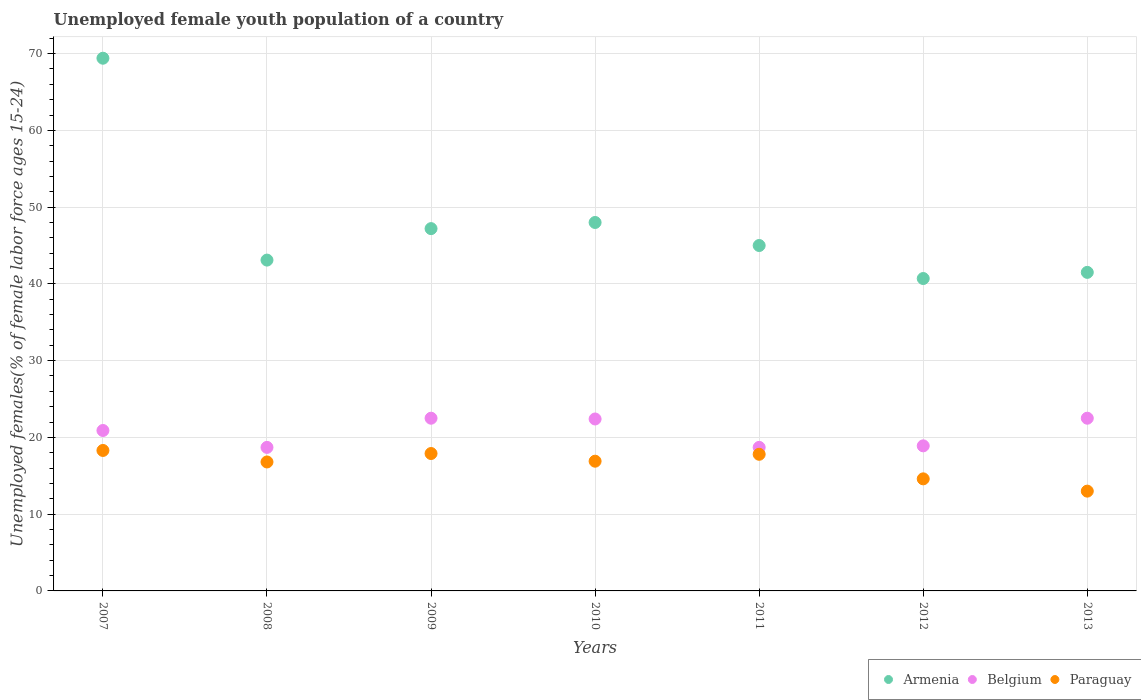Is the number of dotlines equal to the number of legend labels?
Provide a succinct answer. Yes. What is the percentage of unemployed female youth population in Armenia in 2009?
Give a very brief answer. 47.2. Across all years, what is the maximum percentage of unemployed female youth population in Paraguay?
Offer a terse response. 18.3. Across all years, what is the minimum percentage of unemployed female youth population in Belgium?
Provide a short and direct response. 18.7. In which year was the percentage of unemployed female youth population in Belgium minimum?
Give a very brief answer. 2008. What is the total percentage of unemployed female youth population in Armenia in the graph?
Your response must be concise. 334.9. What is the difference between the percentage of unemployed female youth population in Belgium in 2010 and that in 2012?
Provide a succinct answer. 3.5. What is the difference between the percentage of unemployed female youth population in Belgium in 2013 and the percentage of unemployed female youth population in Paraguay in 2009?
Give a very brief answer. 4.6. What is the average percentage of unemployed female youth population in Paraguay per year?
Your answer should be very brief. 16.47. In the year 2009, what is the difference between the percentage of unemployed female youth population in Armenia and percentage of unemployed female youth population in Belgium?
Your answer should be very brief. 24.7. In how many years, is the percentage of unemployed female youth population in Armenia greater than 24 %?
Offer a terse response. 7. What is the ratio of the percentage of unemployed female youth population in Belgium in 2007 to that in 2009?
Your response must be concise. 0.93. Is the percentage of unemployed female youth population in Armenia in 2009 less than that in 2010?
Your answer should be compact. Yes. What is the difference between the highest and the second highest percentage of unemployed female youth population in Armenia?
Your answer should be compact. 21.4. What is the difference between the highest and the lowest percentage of unemployed female youth population in Belgium?
Give a very brief answer. 3.8. Does the percentage of unemployed female youth population in Armenia monotonically increase over the years?
Provide a short and direct response. No. Is the percentage of unemployed female youth population in Armenia strictly greater than the percentage of unemployed female youth population in Belgium over the years?
Provide a succinct answer. Yes. Is the percentage of unemployed female youth population in Armenia strictly less than the percentage of unemployed female youth population in Belgium over the years?
Provide a short and direct response. No. How many years are there in the graph?
Provide a succinct answer. 7. Are the values on the major ticks of Y-axis written in scientific E-notation?
Your answer should be very brief. No. Does the graph contain any zero values?
Give a very brief answer. No. How many legend labels are there?
Give a very brief answer. 3. How are the legend labels stacked?
Make the answer very short. Horizontal. What is the title of the graph?
Make the answer very short. Unemployed female youth population of a country. What is the label or title of the X-axis?
Your response must be concise. Years. What is the label or title of the Y-axis?
Make the answer very short. Unemployed females(% of female labor force ages 15-24). What is the Unemployed females(% of female labor force ages 15-24) in Armenia in 2007?
Your answer should be very brief. 69.4. What is the Unemployed females(% of female labor force ages 15-24) of Belgium in 2007?
Offer a terse response. 20.9. What is the Unemployed females(% of female labor force ages 15-24) in Paraguay in 2007?
Offer a very short reply. 18.3. What is the Unemployed females(% of female labor force ages 15-24) of Armenia in 2008?
Keep it short and to the point. 43.1. What is the Unemployed females(% of female labor force ages 15-24) of Belgium in 2008?
Provide a short and direct response. 18.7. What is the Unemployed females(% of female labor force ages 15-24) in Paraguay in 2008?
Your answer should be very brief. 16.8. What is the Unemployed females(% of female labor force ages 15-24) in Armenia in 2009?
Ensure brevity in your answer.  47.2. What is the Unemployed females(% of female labor force ages 15-24) of Paraguay in 2009?
Offer a very short reply. 17.9. What is the Unemployed females(% of female labor force ages 15-24) of Armenia in 2010?
Your answer should be very brief. 48. What is the Unemployed females(% of female labor force ages 15-24) in Belgium in 2010?
Your answer should be compact. 22.4. What is the Unemployed females(% of female labor force ages 15-24) in Paraguay in 2010?
Make the answer very short. 16.9. What is the Unemployed females(% of female labor force ages 15-24) in Armenia in 2011?
Make the answer very short. 45. What is the Unemployed females(% of female labor force ages 15-24) in Belgium in 2011?
Make the answer very short. 18.7. What is the Unemployed females(% of female labor force ages 15-24) of Paraguay in 2011?
Provide a succinct answer. 17.8. What is the Unemployed females(% of female labor force ages 15-24) in Armenia in 2012?
Offer a terse response. 40.7. What is the Unemployed females(% of female labor force ages 15-24) of Belgium in 2012?
Give a very brief answer. 18.9. What is the Unemployed females(% of female labor force ages 15-24) in Paraguay in 2012?
Your answer should be very brief. 14.6. What is the Unemployed females(% of female labor force ages 15-24) in Armenia in 2013?
Your response must be concise. 41.5. Across all years, what is the maximum Unemployed females(% of female labor force ages 15-24) in Armenia?
Provide a succinct answer. 69.4. Across all years, what is the maximum Unemployed females(% of female labor force ages 15-24) in Belgium?
Ensure brevity in your answer.  22.5. Across all years, what is the maximum Unemployed females(% of female labor force ages 15-24) of Paraguay?
Ensure brevity in your answer.  18.3. Across all years, what is the minimum Unemployed females(% of female labor force ages 15-24) of Armenia?
Provide a short and direct response. 40.7. Across all years, what is the minimum Unemployed females(% of female labor force ages 15-24) in Belgium?
Your answer should be compact. 18.7. What is the total Unemployed females(% of female labor force ages 15-24) in Armenia in the graph?
Your answer should be very brief. 334.9. What is the total Unemployed females(% of female labor force ages 15-24) in Belgium in the graph?
Your answer should be very brief. 144.6. What is the total Unemployed females(% of female labor force ages 15-24) of Paraguay in the graph?
Your response must be concise. 115.3. What is the difference between the Unemployed females(% of female labor force ages 15-24) in Armenia in 2007 and that in 2008?
Provide a succinct answer. 26.3. What is the difference between the Unemployed females(% of female labor force ages 15-24) of Paraguay in 2007 and that in 2009?
Your answer should be compact. 0.4. What is the difference between the Unemployed females(% of female labor force ages 15-24) in Armenia in 2007 and that in 2010?
Give a very brief answer. 21.4. What is the difference between the Unemployed females(% of female labor force ages 15-24) of Paraguay in 2007 and that in 2010?
Make the answer very short. 1.4. What is the difference between the Unemployed females(% of female labor force ages 15-24) of Armenia in 2007 and that in 2011?
Make the answer very short. 24.4. What is the difference between the Unemployed females(% of female labor force ages 15-24) in Paraguay in 2007 and that in 2011?
Ensure brevity in your answer.  0.5. What is the difference between the Unemployed females(% of female labor force ages 15-24) in Armenia in 2007 and that in 2012?
Your answer should be compact. 28.7. What is the difference between the Unemployed females(% of female labor force ages 15-24) in Belgium in 2007 and that in 2012?
Your response must be concise. 2. What is the difference between the Unemployed females(% of female labor force ages 15-24) in Paraguay in 2007 and that in 2012?
Give a very brief answer. 3.7. What is the difference between the Unemployed females(% of female labor force ages 15-24) of Armenia in 2007 and that in 2013?
Provide a short and direct response. 27.9. What is the difference between the Unemployed females(% of female labor force ages 15-24) of Belgium in 2007 and that in 2013?
Provide a short and direct response. -1.6. What is the difference between the Unemployed females(% of female labor force ages 15-24) of Paraguay in 2007 and that in 2013?
Offer a terse response. 5.3. What is the difference between the Unemployed females(% of female labor force ages 15-24) of Armenia in 2008 and that in 2009?
Offer a very short reply. -4.1. What is the difference between the Unemployed females(% of female labor force ages 15-24) of Belgium in 2008 and that in 2009?
Offer a terse response. -3.8. What is the difference between the Unemployed females(% of female labor force ages 15-24) in Armenia in 2008 and that in 2011?
Your answer should be very brief. -1.9. What is the difference between the Unemployed females(% of female labor force ages 15-24) in Belgium in 2008 and that in 2011?
Ensure brevity in your answer.  0. What is the difference between the Unemployed females(% of female labor force ages 15-24) in Belgium in 2008 and that in 2012?
Keep it short and to the point. -0.2. What is the difference between the Unemployed females(% of female labor force ages 15-24) of Paraguay in 2008 and that in 2012?
Give a very brief answer. 2.2. What is the difference between the Unemployed females(% of female labor force ages 15-24) of Belgium in 2008 and that in 2013?
Keep it short and to the point. -3.8. What is the difference between the Unemployed females(% of female labor force ages 15-24) in Paraguay in 2008 and that in 2013?
Give a very brief answer. 3.8. What is the difference between the Unemployed females(% of female labor force ages 15-24) of Belgium in 2009 and that in 2010?
Ensure brevity in your answer.  0.1. What is the difference between the Unemployed females(% of female labor force ages 15-24) in Armenia in 2009 and that in 2011?
Make the answer very short. 2.2. What is the difference between the Unemployed females(% of female labor force ages 15-24) of Paraguay in 2009 and that in 2011?
Ensure brevity in your answer.  0.1. What is the difference between the Unemployed females(% of female labor force ages 15-24) of Belgium in 2009 and that in 2012?
Give a very brief answer. 3.6. What is the difference between the Unemployed females(% of female labor force ages 15-24) of Armenia in 2009 and that in 2013?
Ensure brevity in your answer.  5.7. What is the difference between the Unemployed females(% of female labor force ages 15-24) in Belgium in 2009 and that in 2013?
Your answer should be very brief. 0. What is the difference between the Unemployed females(% of female labor force ages 15-24) in Paraguay in 2009 and that in 2013?
Your answer should be very brief. 4.9. What is the difference between the Unemployed females(% of female labor force ages 15-24) in Armenia in 2010 and that in 2011?
Ensure brevity in your answer.  3. What is the difference between the Unemployed females(% of female labor force ages 15-24) in Paraguay in 2010 and that in 2011?
Make the answer very short. -0.9. What is the difference between the Unemployed females(% of female labor force ages 15-24) of Belgium in 2010 and that in 2012?
Your response must be concise. 3.5. What is the difference between the Unemployed females(% of female labor force ages 15-24) in Paraguay in 2010 and that in 2012?
Offer a terse response. 2.3. What is the difference between the Unemployed females(% of female labor force ages 15-24) in Armenia in 2010 and that in 2013?
Your response must be concise. 6.5. What is the difference between the Unemployed females(% of female labor force ages 15-24) of Belgium in 2011 and that in 2012?
Give a very brief answer. -0.2. What is the difference between the Unemployed females(% of female labor force ages 15-24) of Paraguay in 2011 and that in 2012?
Your answer should be very brief. 3.2. What is the difference between the Unemployed females(% of female labor force ages 15-24) in Armenia in 2011 and that in 2013?
Offer a terse response. 3.5. What is the difference between the Unemployed females(% of female labor force ages 15-24) of Belgium in 2011 and that in 2013?
Keep it short and to the point. -3.8. What is the difference between the Unemployed females(% of female labor force ages 15-24) of Belgium in 2012 and that in 2013?
Keep it short and to the point. -3.6. What is the difference between the Unemployed females(% of female labor force ages 15-24) in Armenia in 2007 and the Unemployed females(% of female labor force ages 15-24) in Belgium in 2008?
Make the answer very short. 50.7. What is the difference between the Unemployed females(% of female labor force ages 15-24) in Armenia in 2007 and the Unemployed females(% of female labor force ages 15-24) in Paraguay in 2008?
Provide a short and direct response. 52.6. What is the difference between the Unemployed females(% of female labor force ages 15-24) in Armenia in 2007 and the Unemployed females(% of female labor force ages 15-24) in Belgium in 2009?
Your response must be concise. 46.9. What is the difference between the Unemployed females(% of female labor force ages 15-24) in Armenia in 2007 and the Unemployed females(% of female labor force ages 15-24) in Paraguay in 2009?
Your response must be concise. 51.5. What is the difference between the Unemployed females(% of female labor force ages 15-24) in Belgium in 2007 and the Unemployed females(% of female labor force ages 15-24) in Paraguay in 2009?
Keep it short and to the point. 3. What is the difference between the Unemployed females(% of female labor force ages 15-24) of Armenia in 2007 and the Unemployed females(% of female labor force ages 15-24) of Belgium in 2010?
Your answer should be very brief. 47. What is the difference between the Unemployed females(% of female labor force ages 15-24) in Armenia in 2007 and the Unemployed females(% of female labor force ages 15-24) in Paraguay in 2010?
Your answer should be very brief. 52.5. What is the difference between the Unemployed females(% of female labor force ages 15-24) of Armenia in 2007 and the Unemployed females(% of female labor force ages 15-24) of Belgium in 2011?
Make the answer very short. 50.7. What is the difference between the Unemployed females(% of female labor force ages 15-24) of Armenia in 2007 and the Unemployed females(% of female labor force ages 15-24) of Paraguay in 2011?
Keep it short and to the point. 51.6. What is the difference between the Unemployed females(% of female labor force ages 15-24) in Armenia in 2007 and the Unemployed females(% of female labor force ages 15-24) in Belgium in 2012?
Your response must be concise. 50.5. What is the difference between the Unemployed females(% of female labor force ages 15-24) of Armenia in 2007 and the Unemployed females(% of female labor force ages 15-24) of Paraguay in 2012?
Keep it short and to the point. 54.8. What is the difference between the Unemployed females(% of female labor force ages 15-24) of Belgium in 2007 and the Unemployed females(% of female labor force ages 15-24) of Paraguay in 2012?
Offer a terse response. 6.3. What is the difference between the Unemployed females(% of female labor force ages 15-24) of Armenia in 2007 and the Unemployed females(% of female labor force ages 15-24) of Belgium in 2013?
Your answer should be compact. 46.9. What is the difference between the Unemployed females(% of female labor force ages 15-24) in Armenia in 2007 and the Unemployed females(% of female labor force ages 15-24) in Paraguay in 2013?
Offer a terse response. 56.4. What is the difference between the Unemployed females(% of female labor force ages 15-24) in Armenia in 2008 and the Unemployed females(% of female labor force ages 15-24) in Belgium in 2009?
Your response must be concise. 20.6. What is the difference between the Unemployed females(% of female labor force ages 15-24) in Armenia in 2008 and the Unemployed females(% of female labor force ages 15-24) in Paraguay in 2009?
Ensure brevity in your answer.  25.2. What is the difference between the Unemployed females(% of female labor force ages 15-24) in Armenia in 2008 and the Unemployed females(% of female labor force ages 15-24) in Belgium in 2010?
Ensure brevity in your answer.  20.7. What is the difference between the Unemployed females(% of female labor force ages 15-24) of Armenia in 2008 and the Unemployed females(% of female labor force ages 15-24) of Paraguay in 2010?
Offer a very short reply. 26.2. What is the difference between the Unemployed females(% of female labor force ages 15-24) in Armenia in 2008 and the Unemployed females(% of female labor force ages 15-24) in Belgium in 2011?
Keep it short and to the point. 24.4. What is the difference between the Unemployed females(% of female labor force ages 15-24) of Armenia in 2008 and the Unemployed females(% of female labor force ages 15-24) of Paraguay in 2011?
Provide a short and direct response. 25.3. What is the difference between the Unemployed females(% of female labor force ages 15-24) of Belgium in 2008 and the Unemployed females(% of female labor force ages 15-24) of Paraguay in 2011?
Keep it short and to the point. 0.9. What is the difference between the Unemployed females(% of female labor force ages 15-24) in Armenia in 2008 and the Unemployed females(% of female labor force ages 15-24) in Belgium in 2012?
Provide a short and direct response. 24.2. What is the difference between the Unemployed females(% of female labor force ages 15-24) of Armenia in 2008 and the Unemployed females(% of female labor force ages 15-24) of Belgium in 2013?
Offer a terse response. 20.6. What is the difference between the Unemployed females(% of female labor force ages 15-24) in Armenia in 2008 and the Unemployed females(% of female labor force ages 15-24) in Paraguay in 2013?
Offer a very short reply. 30.1. What is the difference between the Unemployed females(% of female labor force ages 15-24) in Belgium in 2008 and the Unemployed females(% of female labor force ages 15-24) in Paraguay in 2013?
Give a very brief answer. 5.7. What is the difference between the Unemployed females(% of female labor force ages 15-24) of Armenia in 2009 and the Unemployed females(% of female labor force ages 15-24) of Belgium in 2010?
Offer a terse response. 24.8. What is the difference between the Unemployed females(% of female labor force ages 15-24) of Armenia in 2009 and the Unemployed females(% of female labor force ages 15-24) of Paraguay in 2010?
Offer a terse response. 30.3. What is the difference between the Unemployed females(% of female labor force ages 15-24) in Belgium in 2009 and the Unemployed females(% of female labor force ages 15-24) in Paraguay in 2010?
Ensure brevity in your answer.  5.6. What is the difference between the Unemployed females(% of female labor force ages 15-24) in Armenia in 2009 and the Unemployed females(% of female labor force ages 15-24) in Paraguay in 2011?
Your answer should be compact. 29.4. What is the difference between the Unemployed females(% of female labor force ages 15-24) in Belgium in 2009 and the Unemployed females(% of female labor force ages 15-24) in Paraguay in 2011?
Keep it short and to the point. 4.7. What is the difference between the Unemployed females(% of female labor force ages 15-24) of Armenia in 2009 and the Unemployed females(% of female labor force ages 15-24) of Belgium in 2012?
Your response must be concise. 28.3. What is the difference between the Unemployed females(% of female labor force ages 15-24) of Armenia in 2009 and the Unemployed females(% of female labor force ages 15-24) of Paraguay in 2012?
Offer a terse response. 32.6. What is the difference between the Unemployed females(% of female labor force ages 15-24) in Armenia in 2009 and the Unemployed females(% of female labor force ages 15-24) in Belgium in 2013?
Keep it short and to the point. 24.7. What is the difference between the Unemployed females(% of female labor force ages 15-24) of Armenia in 2009 and the Unemployed females(% of female labor force ages 15-24) of Paraguay in 2013?
Offer a terse response. 34.2. What is the difference between the Unemployed females(% of female labor force ages 15-24) of Belgium in 2009 and the Unemployed females(% of female labor force ages 15-24) of Paraguay in 2013?
Offer a very short reply. 9.5. What is the difference between the Unemployed females(% of female labor force ages 15-24) in Armenia in 2010 and the Unemployed females(% of female labor force ages 15-24) in Belgium in 2011?
Provide a succinct answer. 29.3. What is the difference between the Unemployed females(% of female labor force ages 15-24) in Armenia in 2010 and the Unemployed females(% of female labor force ages 15-24) in Paraguay in 2011?
Give a very brief answer. 30.2. What is the difference between the Unemployed females(% of female labor force ages 15-24) in Armenia in 2010 and the Unemployed females(% of female labor force ages 15-24) in Belgium in 2012?
Your response must be concise. 29.1. What is the difference between the Unemployed females(% of female labor force ages 15-24) of Armenia in 2010 and the Unemployed females(% of female labor force ages 15-24) of Paraguay in 2012?
Offer a very short reply. 33.4. What is the difference between the Unemployed females(% of female labor force ages 15-24) of Belgium in 2010 and the Unemployed females(% of female labor force ages 15-24) of Paraguay in 2012?
Provide a short and direct response. 7.8. What is the difference between the Unemployed females(% of female labor force ages 15-24) in Armenia in 2010 and the Unemployed females(% of female labor force ages 15-24) in Paraguay in 2013?
Your answer should be very brief. 35. What is the difference between the Unemployed females(% of female labor force ages 15-24) in Armenia in 2011 and the Unemployed females(% of female labor force ages 15-24) in Belgium in 2012?
Provide a succinct answer. 26.1. What is the difference between the Unemployed females(% of female labor force ages 15-24) of Armenia in 2011 and the Unemployed females(% of female labor force ages 15-24) of Paraguay in 2012?
Keep it short and to the point. 30.4. What is the difference between the Unemployed females(% of female labor force ages 15-24) in Armenia in 2011 and the Unemployed females(% of female labor force ages 15-24) in Belgium in 2013?
Provide a short and direct response. 22.5. What is the difference between the Unemployed females(% of female labor force ages 15-24) of Belgium in 2011 and the Unemployed females(% of female labor force ages 15-24) of Paraguay in 2013?
Provide a succinct answer. 5.7. What is the difference between the Unemployed females(% of female labor force ages 15-24) in Armenia in 2012 and the Unemployed females(% of female labor force ages 15-24) in Paraguay in 2013?
Your answer should be very brief. 27.7. What is the difference between the Unemployed females(% of female labor force ages 15-24) of Belgium in 2012 and the Unemployed females(% of female labor force ages 15-24) of Paraguay in 2013?
Give a very brief answer. 5.9. What is the average Unemployed females(% of female labor force ages 15-24) of Armenia per year?
Make the answer very short. 47.84. What is the average Unemployed females(% of female labor force ages 15-24) of Belgium per year?
Give a very brief answer. 20.66. What is the average Unemployed females(% of female labor force ages 15-24) in Paraguay per year?
Your response must be concise. 16.47. In the year 2007, what is the difference between the Unemployed females(% of female labor force ages 15-24) of Armenia and Unemployed females(% of female labor force ages 15-24) of Belgium?
Provide a succinct answer. 48.5. In the year 2007, what is the difference between the Unemployed females(% of female labor force ages 15-24) of Armenia and Unemployed females(% of female labor force ages 15-24) of Paraguay?
Your answer should be very brief. 51.1. In the year 2007, what is the difference between the Unemployed females(% of female labor force ages 15-24) of Belgium and Unemployed females(% of female labor force ages 15-24) of Paraguay?
Make the answer very short. 2.6. In the year 2008, what is the difference between the Unemployed females(% of female labor force ages 15-24) of Armenia and Unemployed females(% of female labor force ages 15-24) of Belgium?
Offer a terse response. 24.4. In the year 2008, what is the difference between the Unemployed females(% of female labor force ages 15-24) of Armenia and Unemployed females(% of female labor force ages 15-24) of Paraguay?
Offer a very short reply. 26.3. In the year 2009, what is the difference between the Unemployed females(% of female labor force ages 15-24) in Armenia and Unemployed females(% of female labor force ages 15-24) in Belgium?
Offer a very short reply. 24.7. In the year 2009, what is the difference between the Unemployed females(% of female labor force ages 15-24) of Armenia and Unemployed females(% of female labor force ages 15-24) of Paraguay?
Make the answer very short. 29.3. In the year 2009, what is the difference between the Unemployed females(% of female labor force ages 15-24) of Belgium and Unemployed females(% of female labor force ages 15-24) of Paraguay?
Offer a very short reply. 4.6. In the year 2010, what is the difference between the Unemployed females(% of female labor force ages 15-24) in Armenia and Unemployed females(% of female labor force ages 15-24) in Belgium?
Give a very brief answer. 25.6. In the year 2010, what is the difference between the Unemployed females(% of female labor force ages 15-24) in Armenia and Unemployed females(% of female labor force ages 15-24) in Paraguay?
Offer a terse response. 31.1. In the year 2011, what is the difference between the Unemployed females(% of female labor force ages 15-24) of Armenia and Unemployed females(% of female labor force ages 15-24) of Belgium?
Your answer should be very brief. 26.3. In the year 2011, what is the difference between the Unemployed females(% of female labor force ages 15-24) in Armenia and Unemployed females(% of female labor force ages 15-24) in Paraguay?
Provide a succinct answer. 27.2. In the year 2011, what is the difference between the Unemployed females(% of female labor force ages 15-24) in Belgium and Unemployed females(% of female labor force ages 15-24) in Paraguay?
Your response must be concise. 0.9. In the year 2012, what is the difference between the Unemployed females(% of female labor force ages 15-24) of Armenia and Unemployed females(% of female labor force ages 15-24) of Belgium?
Keep it short and to the point. 21.8. In the year 2012, what is the difference between the Unemployed females(% of female labor force ages 15-24) of Armenia and Unemployed females(% of female labor force ages 15-24) of Paraguay?
Ensure brevity in your answer.  26.1. In the year 2013, what is the difference between the Unemployed females(% of female labor force ages 15-24) of Armenia and Unemployed females(% of female labor force ages 15-24) of Belgium?
Provide a succinct answer. 19. In the year 2013, what is the difference between the Unemployed females(% of female labor force ages 15-24) of Armenia and Unemployed females(% of female labor force ages 15-24) of Paraguay?
Ensure brevity in your answer.  28.5. In the year 2013, what is the difference between the Unemployed females(% of female labor force ages 15-24) of Belgium and Unemployed females(% of female labor force ages 15-24) of Paraguay?
Your answer should be very brief. 9.5. What is the ratio of the Unemployed females(% of female labor force ages 15-24) in Armenia in 2007 to that in 2008?
Provide a succinct answer. 1.61. What is the ratio of the Unemployed females(% of female labor force ages 15-24) in Belgium in 2007 to that in 2008?
Your answer should be compact. 1.12. What is the ratio of the Unemployed females(% of female labor force ages 15-24) in Paraguay in 2007 to that in 2008?
Keep it short and to the point. 1.09. What is the ratio of the Unemployed females(% of female labor force ages 15-24) in Armenia in 2007 to that in 2009?
Offer a terse response. 1.47. What is the ratio of the Unemployed females(% of female labor force ages 15-24) of Belgium in 2007 to that in 2009?
Keep it short and to the point. 0.93. What is the ratio of the Unemployed females(% of female labor force ages 15-24) in Paraguay in 2007 to that in 2009?
Your response must be concise. 1.02. What is the ratio of the Unemployed females(% of female labor force ages 15-24) of Armenia in 2007 to that in 2010?
Your response must be concise. 1.45. What is the ratio of the Unemployed females(% of female labor force ages 15-24) of Belgium in 2007 to that in 2010?
Give a very brief answer. 0.93. What is the ratio of the Unemployed females(% of female labor force ages 15-24) of Paraguay in 2007 to that in 2010?
Keep it short and to the point. 1.08. What is the ratio of the Unemployed females(% of female labor force ages 15-24) of Armenia in 2007 to that in 2011?
Ensure brevity in your answer.  1.54. What is the ratio of the Unemployed females(% of female labor force ages 15-24) in Belgium in 2007 to that in 2011?
Keep it short and to the point. 1.12. What is the ratio of the Unemployed females(% of female labor force ages 15-24) in Paraguay in 2007 to that in 2011?
Your answer should be very brief. 1.03. What is the ratio of the Unemployed females(% of female labor force ages 15-24) of Armenia in 2007 to that in 2012?
Your answer should be compact. 1.71. What is the ratio of the Unemployed females(% of female labor force ages 15-24) in Belgium in 2007 to that in 2012?
Offer a very short reply. 1.11. What is the ratio of the Unemployed females(% of female labor force ages 15-24) of Paraguay in 2007 to that in 2012?
Make the answer very short. 1.25. What is the ratio of the Unemployed females(% of female labor force ages 15-24) in Armenia in 2007 to that in 2013?
Offer a very short reply. 1.67. What is the ratio of the Unemployed females(% of female labor force ages 15-24) in Belgium in 2007 to that in 2013?
Offer a terse response. 0.93. What is the ratio of the Unemployed females(% of female labor force ages 15-24) in Paraguay in 2007 to that in 2013?
Offer a terse response. 1.41. What is the ratio of the Unemployed females(% of female labor force ages 15-24) in Armenia in 2008 to that in 2009?
Provide a succinct answer. 0.91. What is the ratio of the Unemployed females(% of female labor force ages 15-24) of Belgium in 2008 to that in 2009?
Your answer should be compact. 0.83. What is the ratio of the Unemployed females(% of female labor force ages 15-24) in Paraguay in 2008 to that in 2009?
Offer a terse response. 0.94. What is the ratio of the Unemployed females(% of female labor force ages 15-24) of Armenia in 2008 to that in 2010?
Ensure brevity in your answer.  0.9. What is the ratio of the Unemployed females(% of female labor force ages 15-24) of Belgium in 2008 to that in 2010?
Offer a very short reply. 0.83. What is the ratio of the Unemployed females(% of female labor force ages 15-24) in Armenia in 2008 to that in 2011?
Offer a terse response. 0.96. What is the ratio of the Unemployed females(% of female labor force ages 15-24) of Paraguay in 2008 to that in 2011?
Make the answer very short. 0.94. What is the ratio of the Unemployed females(% of female labor force ages 15-24) in Armenia in 2008 to that in 2012?
Your answer should be compact. 1.06. What is the ratio of the Unemployed females(% of female labor force ages 15-24) in Belgium in 2008 to that in 2012?
Make the answer very short. 0.99. What is the ratio of the Unemployed females(% of female labor force ages 15-24) of Paraguay in 2008 to that in 2012?
Offer a very short reply. 1.15. What is the ratio of the Unemployed females(% of female labor force ages 15-24) in Armenia in 2008 to that in 2013?
Ensure brevity in your answer.  1.04. What is the ratio of the Unemployed females(% of female labor force ages 15-24) of Belgium in 2008 to that in 2013?
Offer a very short reply. 0.83. What is the ratio of the Unemployed females(% of female labor force ages 15-24) of Paraguay in 2008 to that in 2013?
Your answer should be very brief. 1.29. What is the ratio of the Unemployed females(% of female labor force ages 15-24) in Armenia in 2009 to that in 2010?
Offer a terse response. 0.98. What is the ratio of the Unemployed females(% of female labor force ages 15-24) of Belgium in 2009 to that in 2010?
Provide a short and direct response. 1. What is the ratio of the Unemployed females(% of female labor force ages 15-24) in Paraguay in 2009 to that in 2010?
Provide a short and direct response. 1.06. What is the ratio of the Unemployed females(% of female labor force ages 15-24) of Armenia in 2009 to that in 2011?
Your answer should be very brief. 1.05. What is the ratio of the Unemployed females(% of female labor force ages 15-24) of Belgium in 2009 to that in 2011?
Ensure brevity in your answer.  1.2. What is the ratio of the Unemployed females(% of female labor force ages 15-24) in Paraguay in 2009 to that in 2011?
Your answer should be compact. 1.01. What is the ratio of the Unemployed females(% of female labor force ages 15-24) of Armenia in 2009 to that in 2012?
Your answer should be compact. 1.16. What is the ratio of the Unemployed females(% of female labor force ages 15-24) of Belgium in 2009 to that in 2012?
Offer a very short reply. 1.19. What is the ratio of the Unemployed females(% of female labor force ages 15-24) in Paraguay in 2009 to that in 2012?
Offer a very short reply. 1.23. What is the ratio of the Unemployed females(% of female labor force ages 15-24) in Armenia in 2009 to that in 2013?
Keep it short and to the point. 1.14. What is the ratio of the Unemployed females(% of female labor force ages 15-24) of Belgium in 2009 to that in 2013?
Ensure brevity in your answer.  1. What is the ratio of the Unemployed females(% of female labor force ages 15-24) of Paraguay in 2009 to that in 2013?
Offer a terse response. 1.38. What is the ratio of the Unemployed females(% of female labor force ages 15-24) of Armenia in 2010 to that in 2011?
Make the answer very short. 1.07. What is the ratio of the Unemployed females(% of female labor force ages 15-24) in Belgium in 2010 to that in 2011?
Keep it short and to the point. 1.2. What is the ratio of the Unemployed females(% of female labor force ages 15-24) of Paraguay in 2010 to that in 2011?
Your response must be concise. 0.95. What is the ratio of the Unemployed females(% of female labor force ages 15-24) of Armenia in 2010 to that in 2012?
Provide a succinct answer. 1.18. What is the ratio of the Unemployed females(% of female labor force ages 15-24) of Belgium in 2010 to that in 2012?
Provide a short and direct response. 1.19. What is the ratio of the Unemployed females(% of female labor force ages 15-24) in Paraguay in 2010 to that in 2012?
Provide a succinct answer. 1.16. What is the ratio of the Unemployed females(% of female labor force ages 15-24) in Armenia in 2010 to that in 2013?
Keep it short and to the point. 1.16. What is the ratio of the Unemployed females(% of female labor force ages 15-24) in Belgium in 2010 to that in 2013?
Keep it short and to the point. 1. What is the ratio of the Unemployed females(% of female labor force ages 15-24) in Paraguay in 2010 to that in 2013?
Provide a short and direct response. 1.3. What is the ratio of the Unemployed females(% of female labor force ages 15-24) in Armenia in 2011 to that in 2012?
Offer a very short reply. 1.11. What is the ratio of the Unemployed females(% of female labor force ages 15-24) in Belgium in 2011 to that in 2012?
Provide a short and direct response. 0.99. What is the ratio of the Unemployed females(% of female labor force ages 15-24) of Paraguay in 2011 to that in 2012?
Give a very brief answer. 1.22. What is the ratio of the Unemployed females(% of female labor force ages 15-24) of Armenia in 2011 to that in 2013?
Provide a succinct answer. 1.08. What is the ratio of the Unemployed females(% of female labor force ages 15-24) in Belgium in 2011 to that in 2013?
Keep it short and to the point. 0.83. What is the ratio of the Unemployed females(% of female labor force ages 15-24) in Paraguay in 2011 to that in 2013?
Give a very brief answer. 1.37. What is the ratio of the Unemployed females(% of female labor force ages 15-24) in Armenia in 2012 to that in 2013?
Provide a succinct answer. 0.98. What is the ratio of the Unemployed females(% of female labor force ages 15-24) of Belgium in 2012 to that in 2013?
Offer a very short reply. 0.84. What is the ratio of the Unemployed females(% of female labor force ages 15-24) of Paraguay in 2012 to that in 2013?
Make the answer very short. 1.12. What is the difference between the highest and the second highest Unemployed females(% of female labor force ages 15-24) of Armenia?
Keep it short and to the point. 21.4. What is the difference between the highest and the second highest Unemployed females(% of female labor force ages 15-24) in Belgium?
Keep it short and to the point. 0. What is the difference between the highest and the lowest Unemployed females(% of female labor force ages 15-24) of Armenia?
Your answer should be very brief. 28.7. 